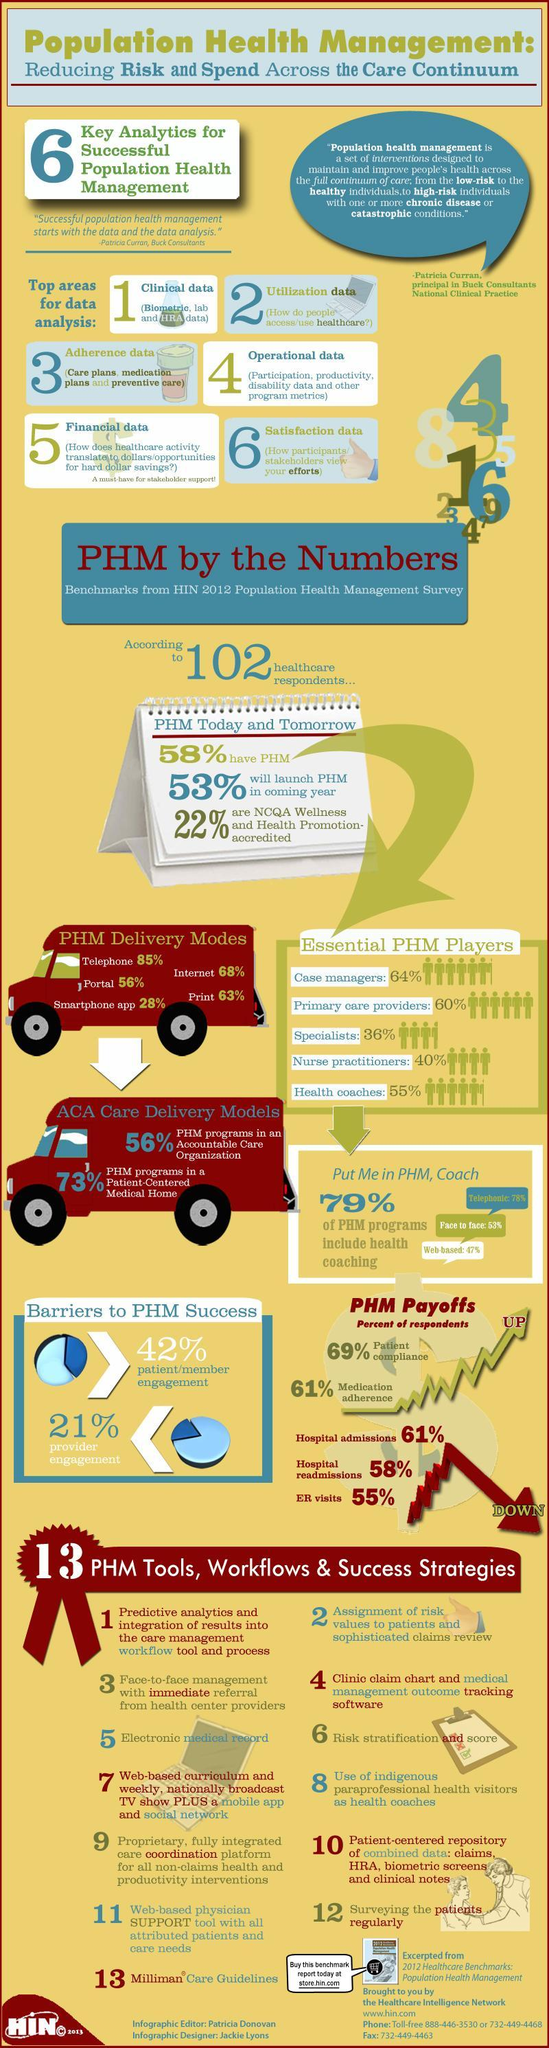What percentage are not NCQA wellness and Health promotion-accredited?
Answer the question with a short phrase. 78% What is the percentage of provider engagement? 21% What percentage don't have PHM? 42% Which all are the barriers to PHM success? patient/member engagement, provider engagement What percentage of PHM programs is not in a patient-centered medical home? 27% What is the number of essential PHM players? 5 What percentage of PHM programs is not in an accountable care organization? 44% 